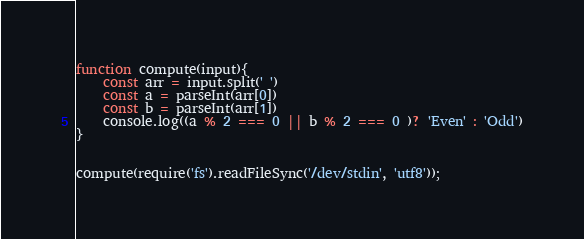<code> <loc_0><loc_0><loc_500><loc_500><_JavaScript_>function compute(input){
	const arr = input.split(' ')
    const a = parseInt(arr[0])
    const b = parseInt(arr[1])
    console.log((a % 2 === 0 || b % 2 === 0 )? 'Even' : 'Odd')
}


compute(require('fs').readFileSync('/dev/stdin', 'utf8'));</code> 